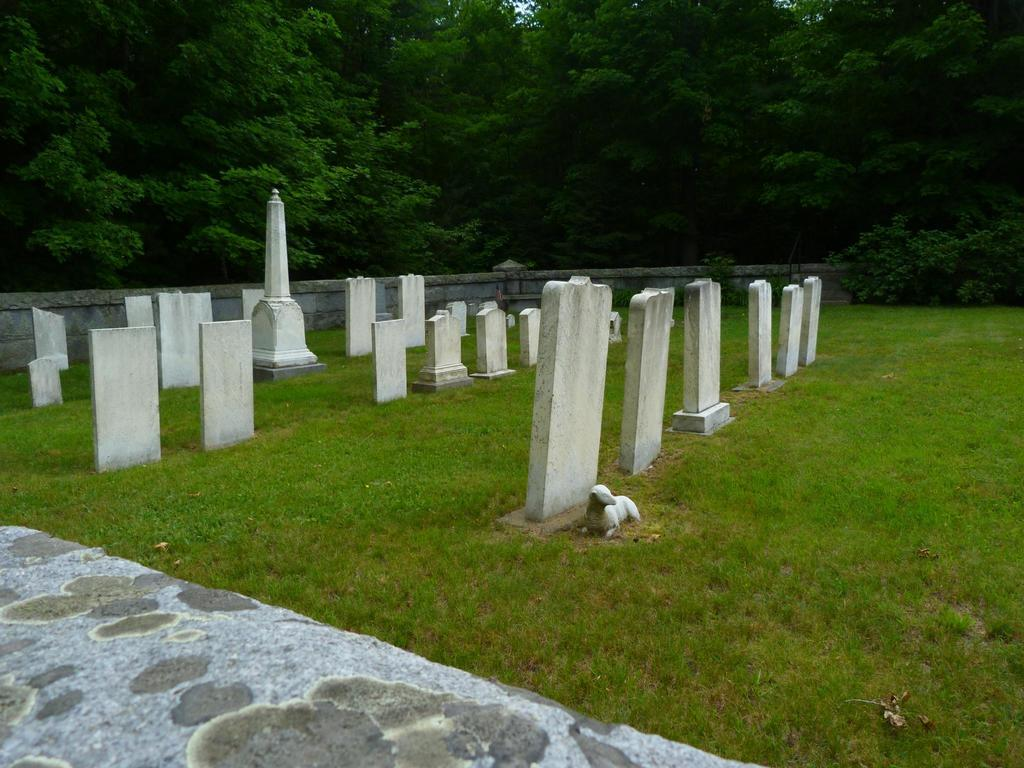What type of land is visible in the image? There are cemeteries on the grassland in the image. What can be seen on one of the cemeteries? An animal is sitting on one of the cemeteries. What is located behind a wall in the image? There are trees behind a wall in the image. What is present at the bottom of the image? There is a stone slab at the bottom of the image. How does the animal express its anger in the image? There is no indication of the animal's emotions in the image, so we cannot determine if it is expressing anger. What shape is the cemetery in the image? The shape of the cemetery is not specified in the image, so we cannot determine if it is a circle or any other shape. 